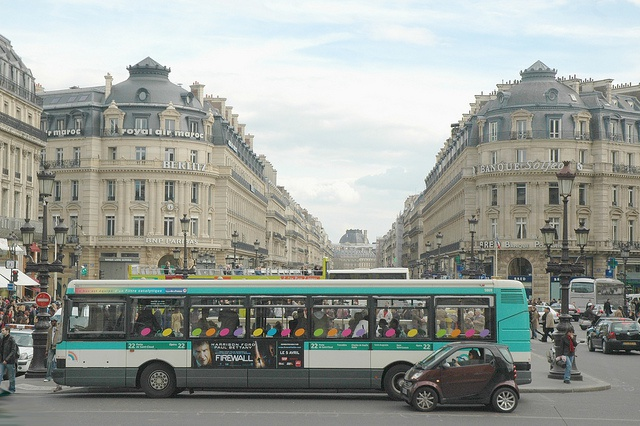Describe the objects in this image and their specific colors. I can see bus in lightgray, gray, black, darkgray, and teal tones, car in lightgray, black, gray, and darkgray tones, car in lightgray, black, gray, and darkgray tones, people in lightgray, gray, black, darkgray, and brown tones, and bus in lightgray, gray, and darkgray tones in this image. 